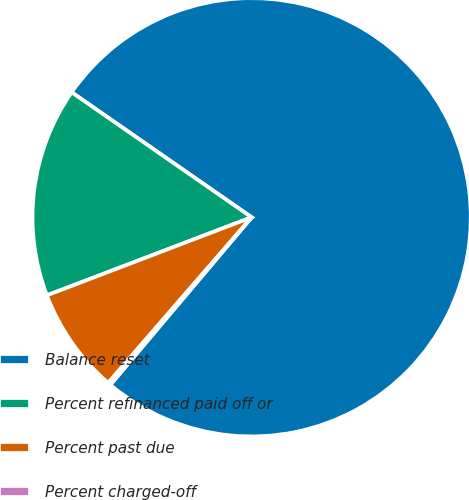Convert chart to OTSL. <chart><loc_0><loc_0><loc_500><loc_500><pie_chart><fcel>Balance reset<fcel>Percent refinanced paid off or<fcel>Percent past due<fcel>Percent charged-off<nl><fcel>76.49%<fcel>15.46%<fcel>7.84%<fcel>0.21%<nl></chart> 